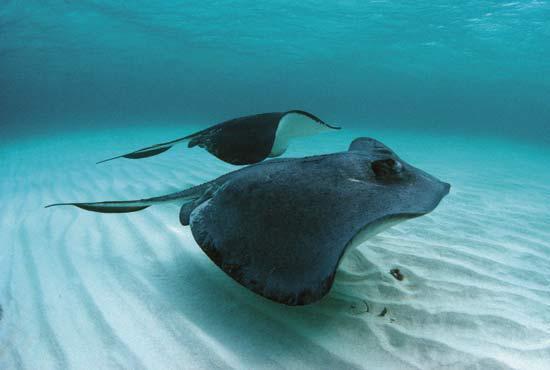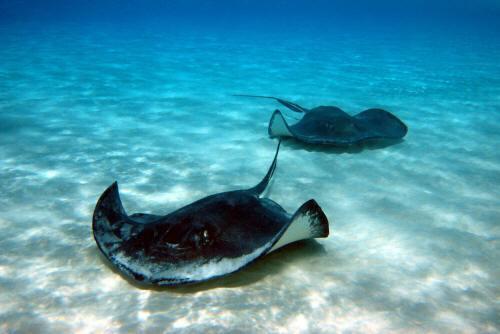The first image is the image on the left, the second image is the image on the right. Evaluate the accuracy of this statement regarding the images: "The left image shows two rays moving toward the right.". Is it true? Answer yes or no. Yes. 